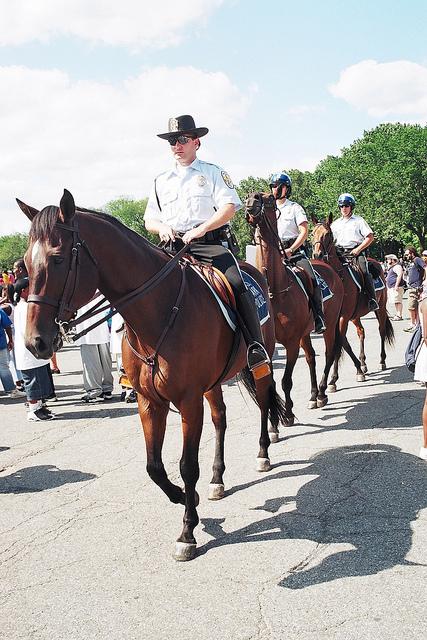How many riders are there?
Keep it brief. 3. Are these race horses?
Write a very short answer. No. Are these horses for recreational or professional use?
Quick response, please. Professional. 